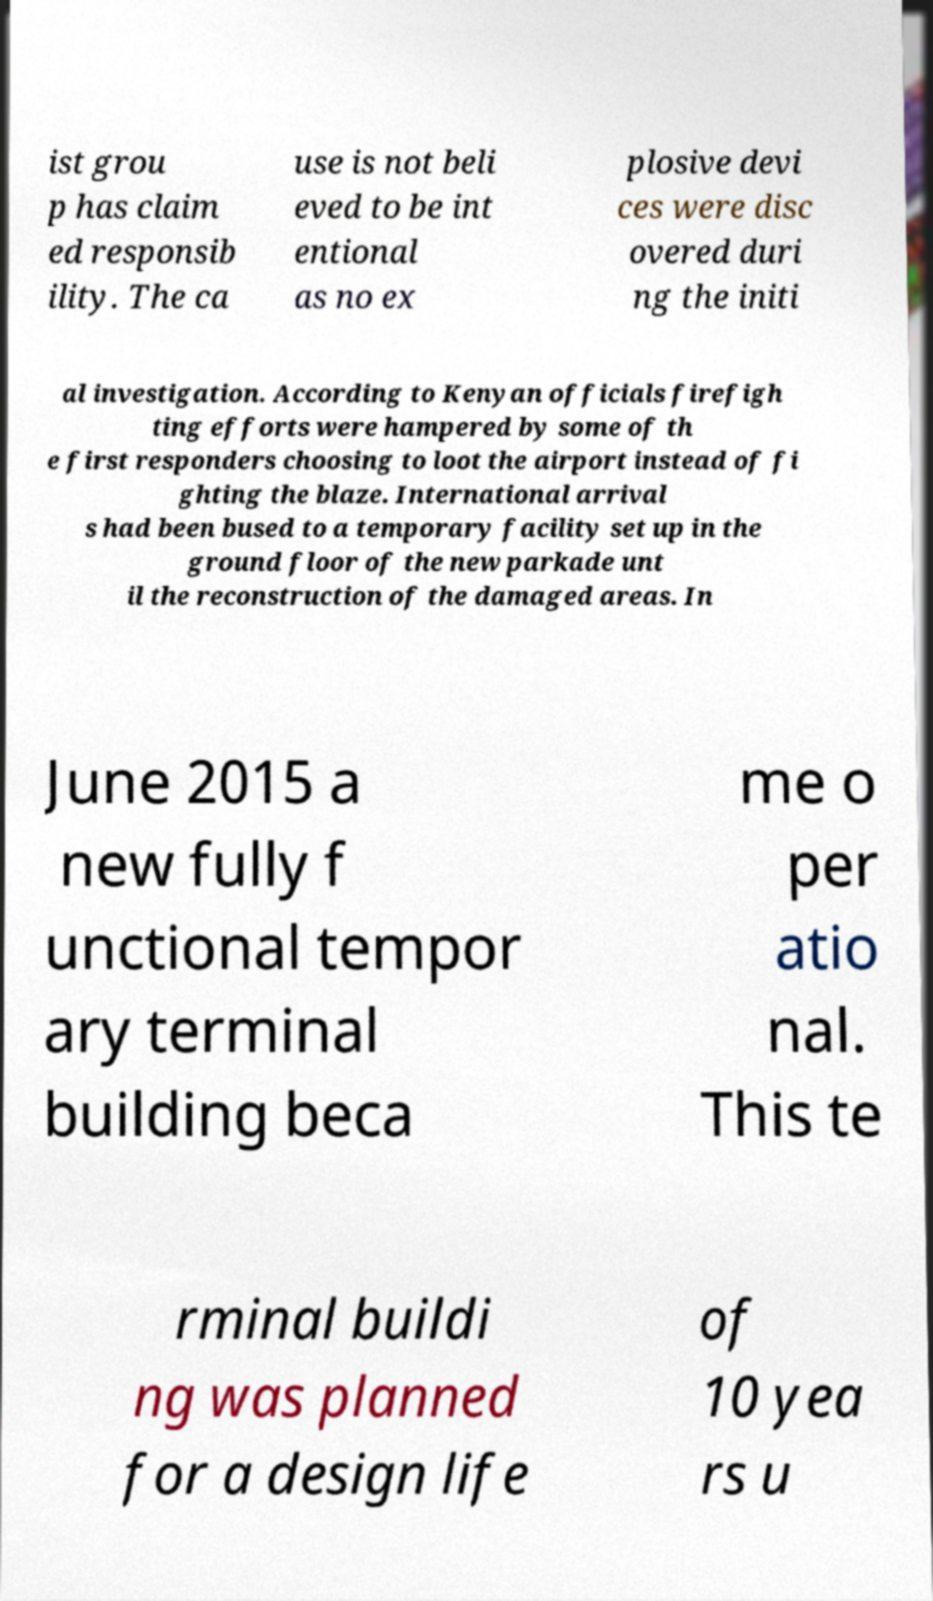Please identify and transcribe the text found in this image. ist grou p has claim ed responsib ility. The ca use is not beli eved to be int entional as no ex plosive devi ces were disc overed duri ng the initi al investigation. According to Kenyan officials firefigh ting efforts were hampered by some of th e first responders choosing to loot the airport instead of fi ghting the blaze. International arrival s had been bused to a temporary facility set up in the ground floor of the new parkade unt il the reconstruction of the damaged areas. In June 2015 a new fully f unctional tempor ary terminal building beca me o per atio nal. This te rminal buildi ng was planned for a design life of 10 yea rs u 